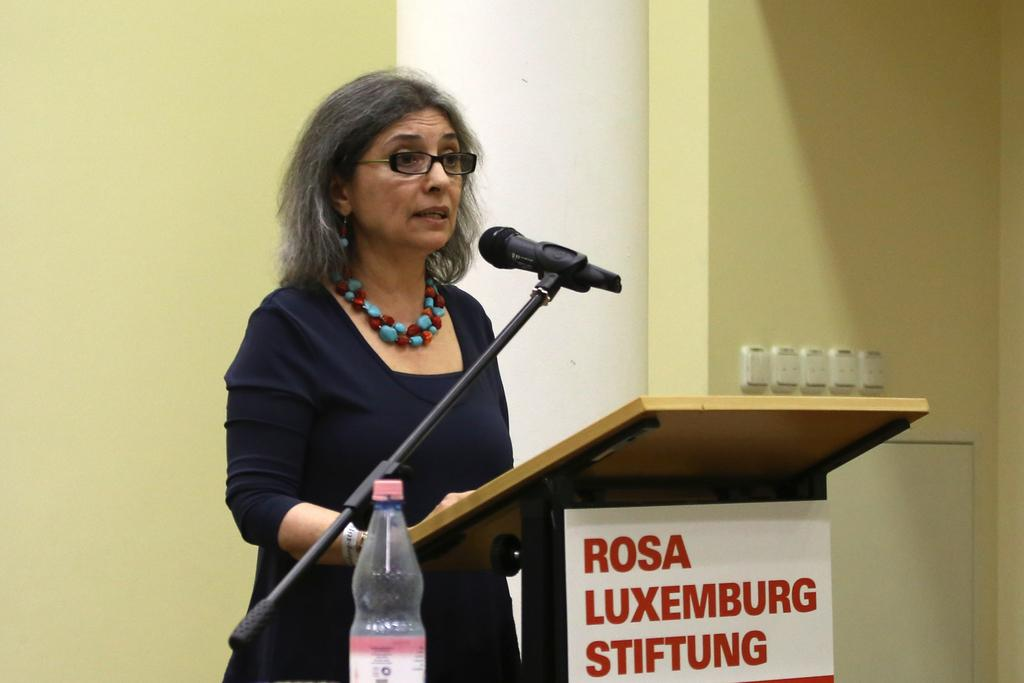Who is the main subject in the image? There is a woman in the image. What is the woman standing in front of? The woman is standing in front of a speech desk. What object is present for amplifying her voice? There is a microphone in the image. What might the woman be using for hydration during her speech? There is a water bottle in the image. What can be seen behind the woman? There is a wall in the background of the image. What is the tax rate in the image? There is no information about tax rates in the image; it features a woman standing in front of a speech desk with a microphone and water bottle. 